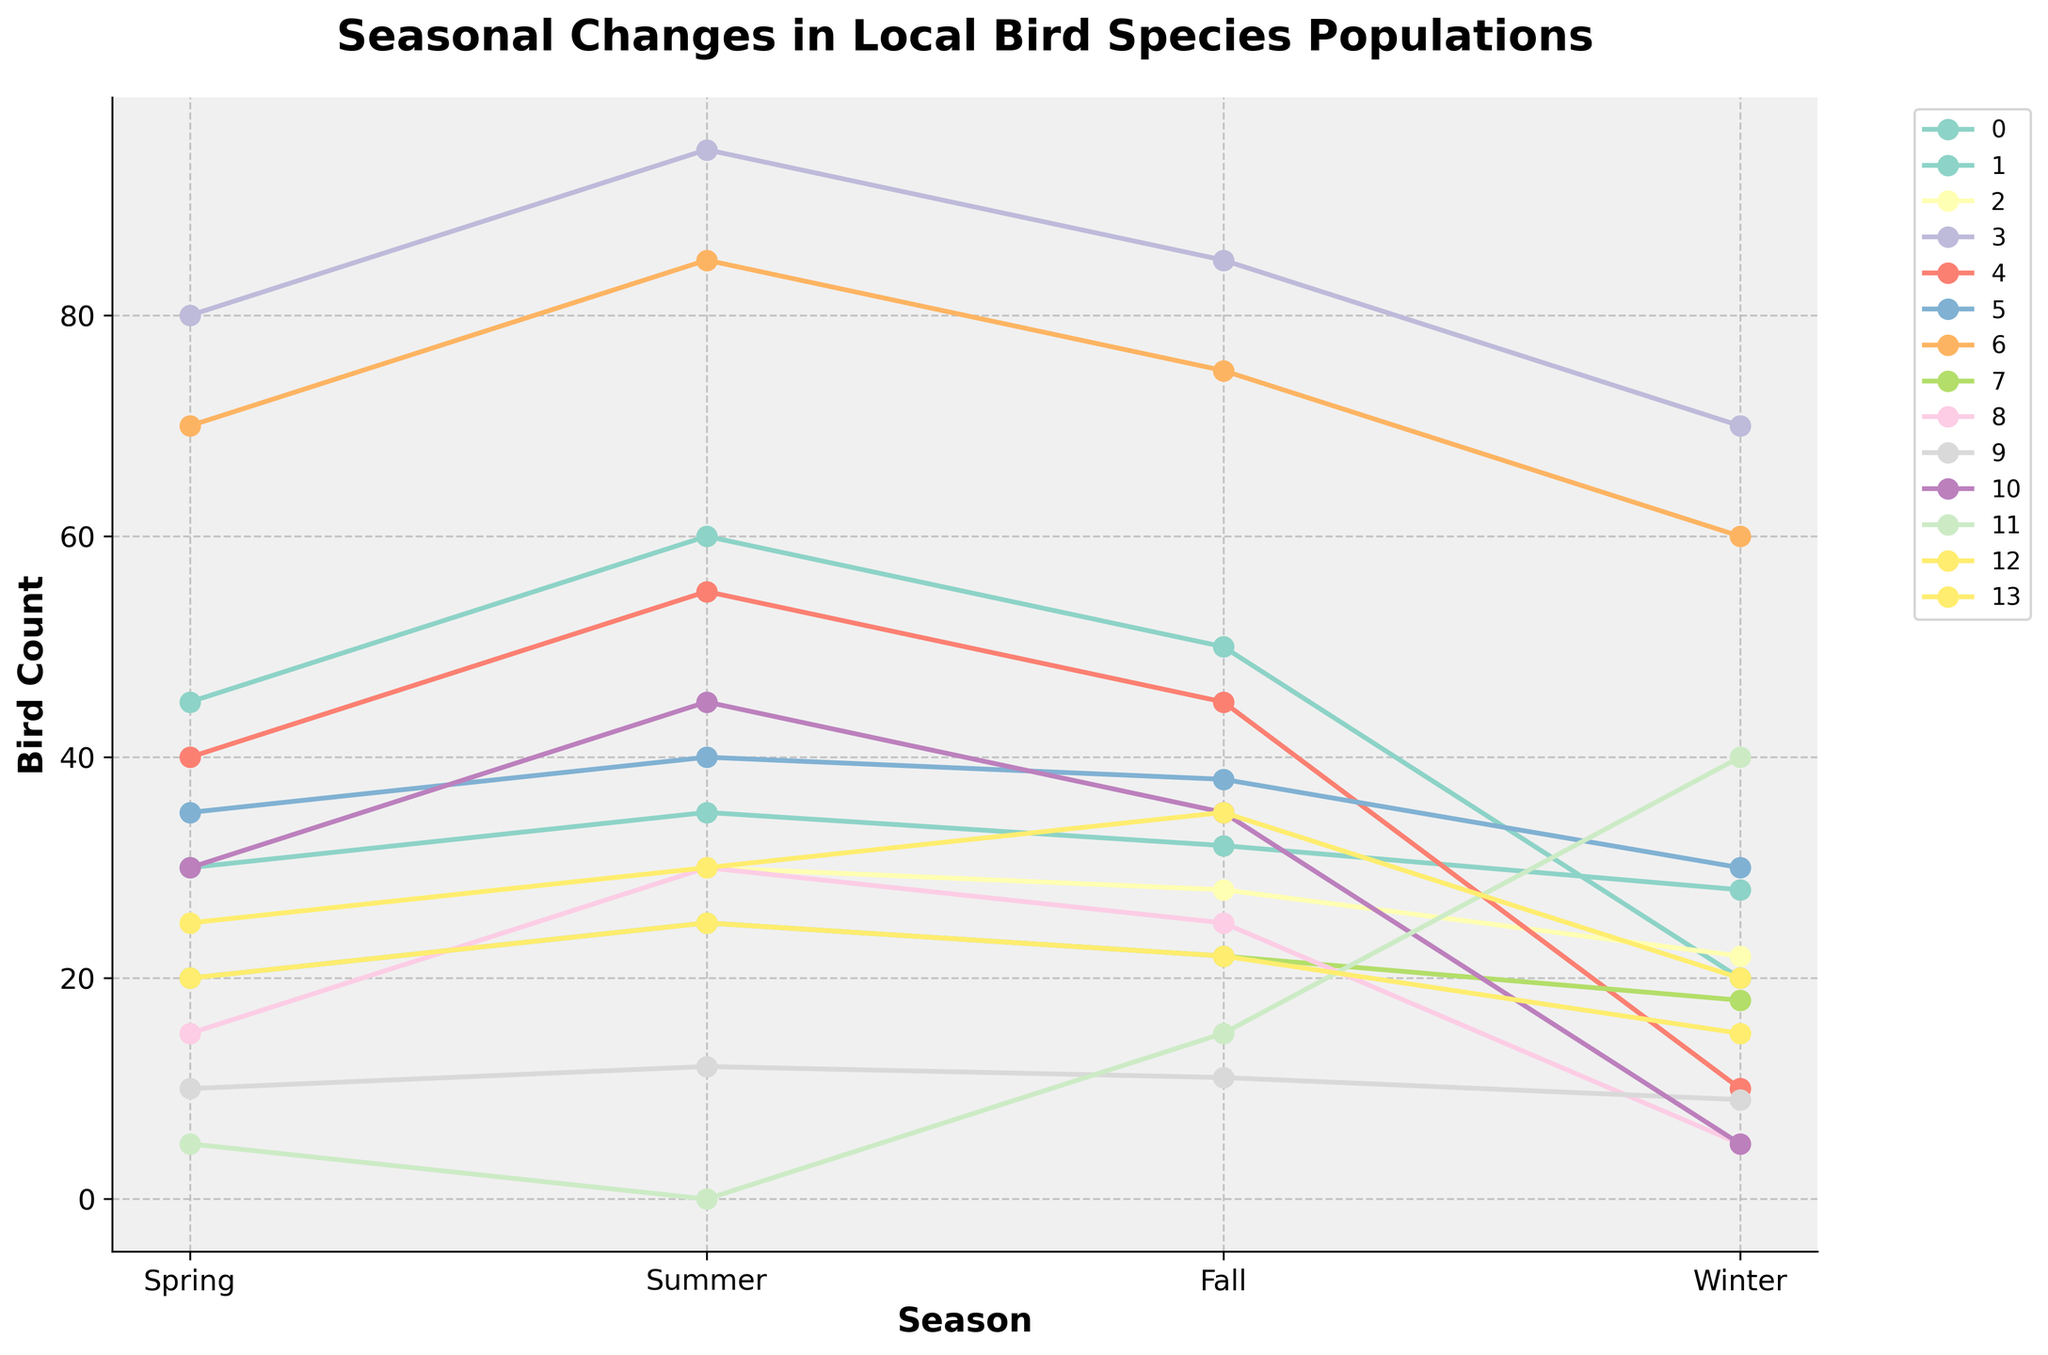Which bird species has the highest population in Winter? To find this, we need to look at the peak value of all lines at the point marked "Winter". By comparing them, it is clear that the House Sparrow has the highest count of 70.
Answer: House Sparrow Which bird species shows the most dramatic decrease from Fall to Winter? To determine this, we look at how the populations change from Fall to Winter and calculate the difference for each species. The American Goldfinch falls from 25 to 5, resulting in a dramatic decrease of 20.
Answer: American Goldfinch Which season has the highest overall bird population when considering all species together? To find this, we sum the population counts for all species for each season and compare them. The counts are: Spring (480), Summer (627), Fall (518), and Winter (377). Summer has the highest overall bird population with 627.
Answer: Summer What is the average population of the Northern Cardinal throughout the seasons? We sum the Northern Cardinal counts for all seasons and then divide by the number of seasons: (30 + 35 + 32 + 28) / 4 = 125 / 4 = 31.25.
Answer: 31.25 Which species has a relatively stable population throughout the year? Looking at the data, the Northern Cardinal populations remain consistent with counts of 30, 35, 32, and 28, showing minor variations.
Answer: Northern Cardinal How does the population of the Dark-eyed Junco change from Spring to Winter? The Dark-eyed Junco starts at 5 in the Spring, drops to 0 in Summer, rises to 15 in Fall, and further increases to 40 in Winter. Most notably, it increases significantly towards Winter.
Answer: Dramatic Increase Which species have their highest populations in Summer? By checking peaks at Summer, American Robin (60), House Sparrow (95), Red-winged Blackbird (55), European Starling (85), American Goldfinch (30), and Common Grackle (45) all have their highest populations in Summer.
Answer: American Robin, House Sparrow, Red-winged Blackbird, European Starling, American Goldfinch, Common Grackle Compare the population trends of the American Robin and the Blue Jay. Both species increase from Spring into Summer, with the American Robin going from 45 to 60 and the Blue Jay from 25 to 30. They both show a slight decrease in Fall and a more significant drop in Winter, with the American Robin ending at 20 and the Blue Jay at 22. Their trends are similar, but the American Robin has higher overall counts.
Answer: Similar trends, American Robin has higher counts How many more House Sparrows are there in Winter compared to the Dark-eyed Junco? The House Sparrow has 70 in Winter, while the Dark-eyed Junco has 40. The difference is 70 - 40 = 30.
Answer: 30 Does any species show an increase in population from Fall to Winter? Comparison of Fall and Winter counts Only the Canada Goose and Dark-eyed Junco show an increase from Fall to Winter. The Canada Goose goes from 35 to 20 (decrease), and the Dark-eyed Junco from 15 to 40 (increase).
Answer: Dark-eyed Junco 